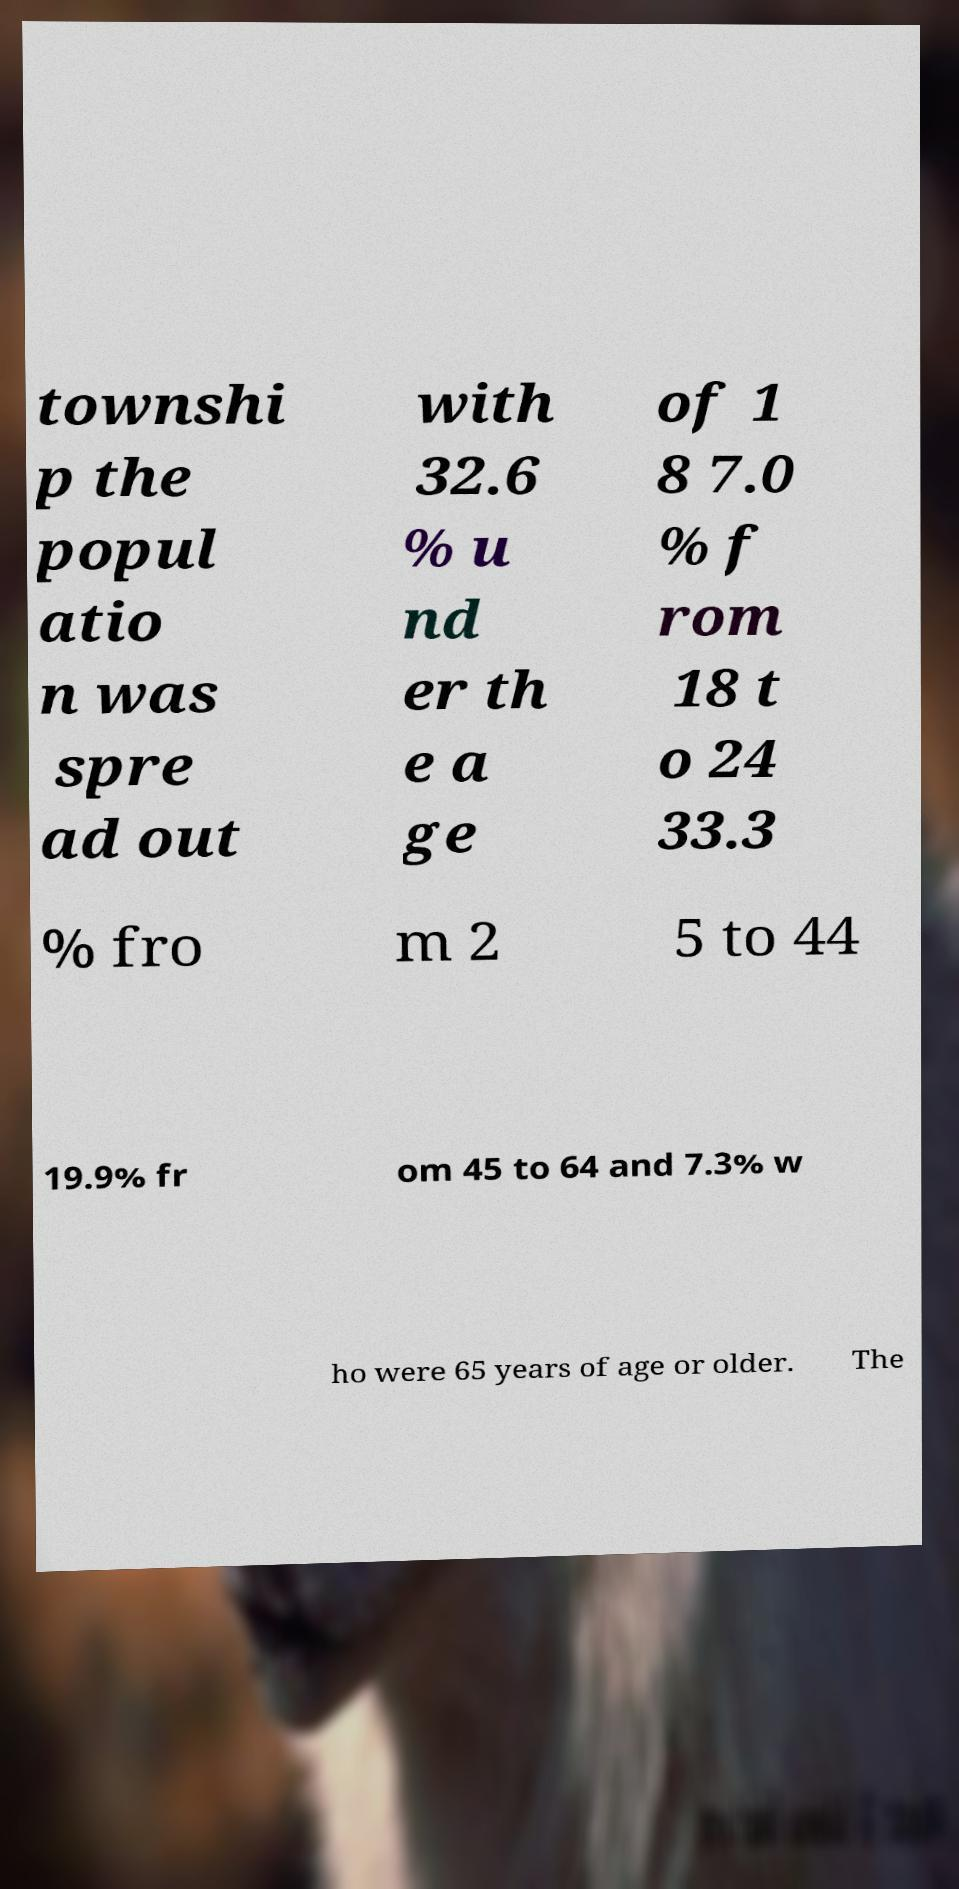Please identify and transcribe the text found in this image. townshi p the popul atio n was spre ad out with 32.6 % u nd er th e a ge of 1 8 7.0 % f rom 18 t o 24 33.3 % fro m 2 5 to 44 19.9% fr om 45 to 64 and 7.3% w ho were 65 years of age or older. The 